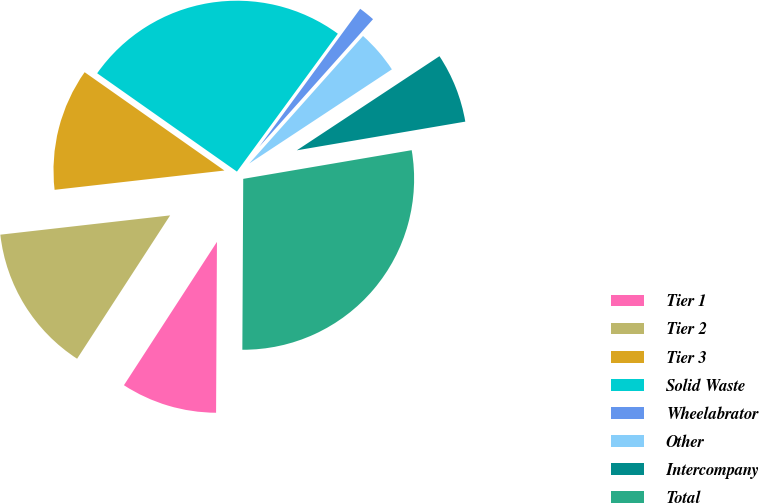Convert chart. <chart><loc_0><loc_0><loc_500><loc_500><pie_chart><fcel>Tier 1<fcel>Tier 2<fcel>Tier 3<fcel>Solid Waste<fcel>Wheelabrator<fcel>Other<fcel>Intercompany<fcel>Total<nl><fcel>9.08%<fcel>14.04%<fcel>11.56%<fcel>25.3%<fcel>1.54%<fcel>4.12%<fcel>6.6%<fcel>27.77%<nl></chart> 